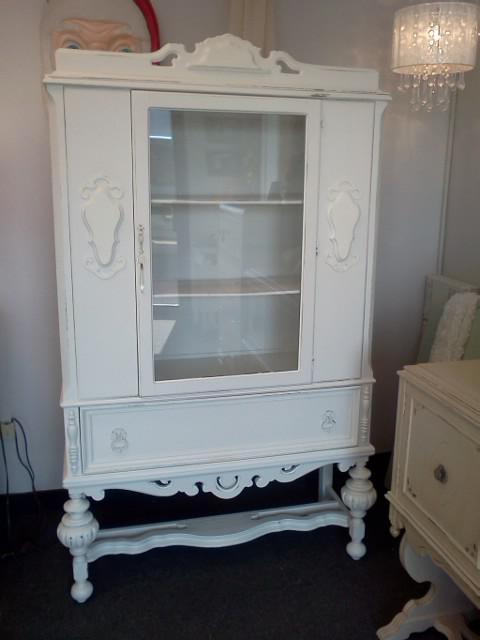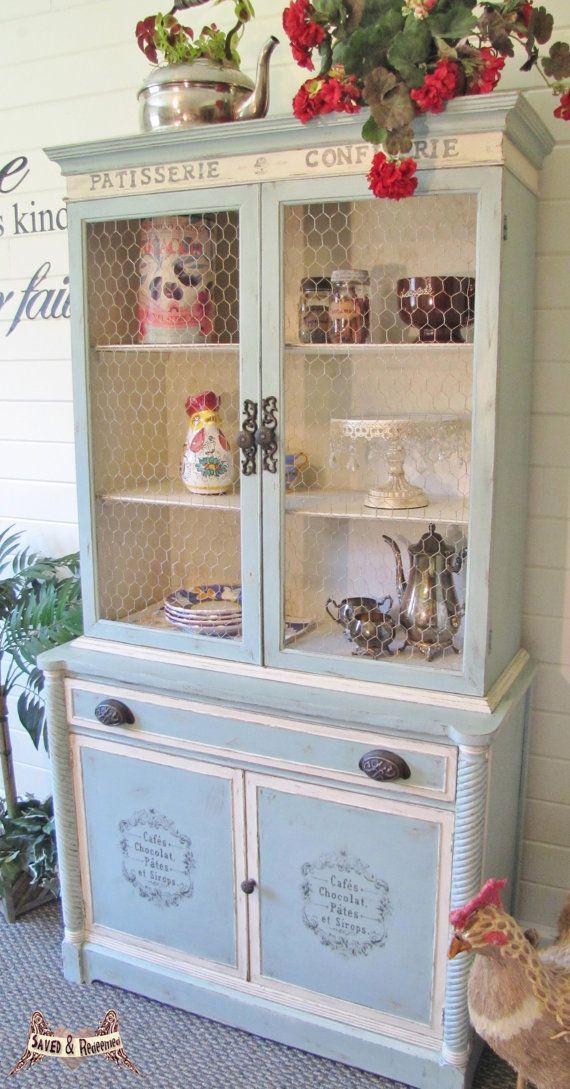The first image is the image on the left, the second image is the image on the right. Evaluate the accuracy of this statement regarding the images: "One wooden hutch has a pair of doors and flat top, while the other has a single centered glass door and rounded decorative detail at the top.". Is it true? Answer yes or no. Yes. The first image is the image on the left, the second image is the image on the right. Analyze the images presented: Is the assertion "The cabinet on the right is set up against a pink wall." valid? Answer yes or no. No. 